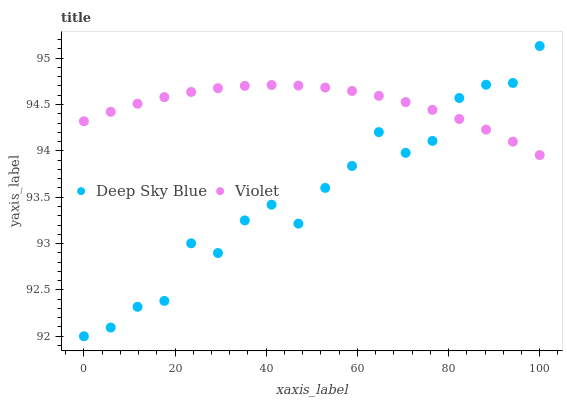Does Deep Sky Blue have the minimum area under the curve?
Answer yes or no. Yes. Does Violet have the maximum area under the curve?
Answer yes or no. Yes. Does Violet have the minimum area under the curve?
Answer yes or no. No. Is Violet the smoothest?
Answer yes or no. Yes. Is Deep Sky Blue the roughest?
Answer yes or no. Yes. Is Violet the roughest?
Answer yes or no. No. Does Deep Sky Blue have the lowest value?
Answer yes or no. Yes. Does Violet have the lowest value?
Answer yes or no. No. Does Deep Sky Blue have the highest value?
Answer yes or no. Yes. Does Violet have the highest value?
Answer yes or no. No. Does Deep Sky Blue intersect Violet?
Answer yes or no. Yes. Is Deep Sky Blue less than Violet?
Answer yes or no. No. Is Deep Sky Blue greater than Violet?
Answer yes or no. No. 